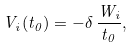<formula> <loc_0><loc_0><loc_500><loc_500>V _ { i } ( t _ { 0 } ) = - \delta \, \frac { W _ { i } } { t _ { 0 } } ,</formula> 